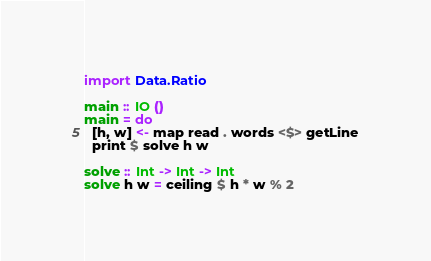<code> <loc_0><loc_0><loc_500><loc_500><_Haskell_>import Data.Ratio

main :: IO ()
main = do
  [h, w] <- map read . words <$> getLine
  print $ solve h w

solve :: Int -> Int -> Int
solve h w = ceiling $ h * w % 2
</code> 